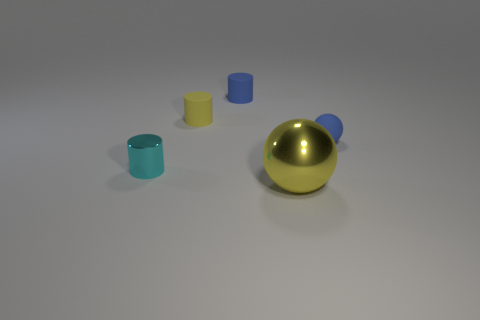Is there any other thing that is the same size as the yellow shiny sphere?
Provide a short and direct response. No. What is the material of the tiny thing that is the same color as the big metal object?
Your answer should be compact. Rubber. Is the size of the rubber sphere the same as the yellow rubber cylinder?
Your answer should be very brief. Yes. There is a tiny thing on the right side of the big metallic thing; are there any tiny blue matte things that are behind it?
Offer a very short reply. Yes. What is the shape of the matte thing that is behind the tiny yellow rubber thing?
Ensure brevity in your answer.  Cylinder. What number of tiny blue rubber balls are in front of the blue matte object that is in front of the tiny rubber cylinder that is to the right of the small yellow thing?
Make the answer very short. 0. Does the cyan cylinder have the same size as the ball behind the shiny cylinder?
Your answer should be compact. Yes. There is a metal object that is right of the tiny matte cylinder to the left of the blue matte cylinder; what is its size?
Provide a succinct answer. Large. How many spheres are the same material as the cyan object?
Your answer should be compact. 1. Is there a large blue cylinder?
Offer a very short reply. No. 